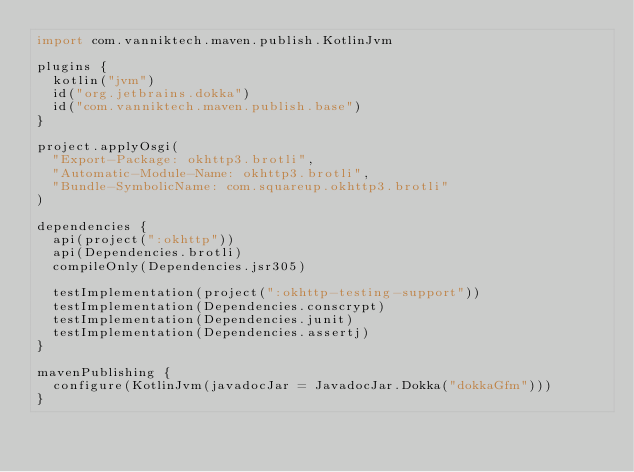<code> <loc_0><loc_0><loc_500><loc_500><_Kotlin_>import com.vanniktech.maven.publish.KotlinJvm

plugins {
  kotlin("jvm")
  id("org.jetbrains.dokka")
  id("com.vanniktech.maven.publish.base")
}

project.applyOsgi(
  "Export-Package: okhttp3.brotli",
  "Automatic-Module-Name: okhttp3.brotli",
  "Bundle-SymbolicName: com.squareup.okhttp3.brotli"
)

dependencies {
  api(project(":okhttp"))
  api(Dependencies.brotli)
  compileOnly(Dependencies.jsr305)

  testImplementation(project(":okhttp-testing-support"))
  testImplementation(Dependencies.conscrypt)
  testImplementation(Dependencies.junit)
  testImplementation(Dependencies.assertj)
}

mavenPublishing {
  configure(KotlinJvm(javadocJar = JavadocJar.Dokka("dokkaGfm")))
}
</code> 